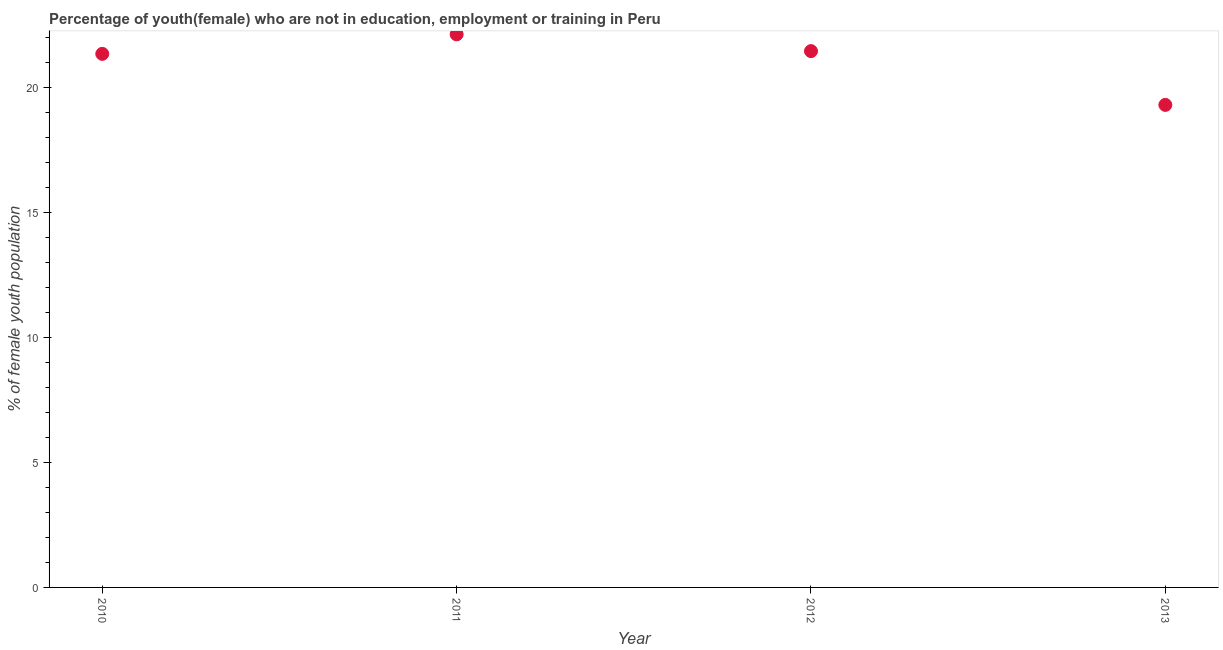What is the unemployed female youth population in 2012?
Your answer should be compact. 21.44. Across all years, what is the maximum unemployed female youth population?
Provide a succinct answer. 22.11. Across all years, what is the minimum unemployed female youth population?
Keep it short and to the point. 19.29. In which year was the unemployed female youth population minimum?
Offer a very short reply. 2013. What is the sum of the unemployed female youth population?
Provide a succinct answer. 84.17. What is the difference between the unemployed female youth population in 2010 and 2012?
Keep it short and to the point. -0.11. What is the average unemployed female youth population per year?
Your answer should be compact. 21.04. What is the median unemployed female youth population?
Your answer should be very brief. 21.39. What is the ratio of the unemployed female youth population in 2012 to that in 2013?
Ensure brevity in your answer.  1.11. Is the unemployed female youth population in 2011 less than that in 2012?
Offer a terse response. No. What is the difference between the highest and the second highest unemployed female youth population?
Provide a succinct answer. 0.67. Is the sum of the unemployed female youth population in 2011 and 2012 greater than the maximum unemployed female youth population across all years?
Your response must be concise. Yes. What is the difference between the highest and the lowest unemployed female youth population?
Keep it short and to the point. 2.82. In how many years, is the unemployed female youth population greater than the average unemployed female youth population taken over all years?
Make the answer very short. 3. Are the values on the major ticks of Y-axis written in scientific E-notation?
Give a very brief answer. No. Does the graph contain any zero values?
Offer a terse response. No. Does the graph contain grids?
Your answer should be compact. No. What is the title of the graph?
Offer a very short reply. Percentage of youth(female) who are not in education, employment or training in Peru. What is the label or title of the X-axis?
Provide a succinct answer. Year. What is the label or title of the Y-axis?
Your response must be concise. % of female youth population. What is the % of female youth population in 2010?
Your answer should be compact. 21.33. What is the % of female youth population in 2011?
Provide a succinct answer. 22.11. What is the % of female youth population in 2012?
Ensure brevity in your answer.  21.44. What is the % of female youth population in 2013?
Make the answer very short. 19.29. What is the difference between the % of female youth population in 2010 and 2011?
Offer a very short reply. -0.78. What is the difference between the % of female youth population in 2010 and 2012?
Your response must be concise. -0.11. What is the difference between the % of female youth population in 2010 and 2013?
Keep it short and to the point. 2.04. What is the difference between the % of female youth population in 2011 and 2012?
Your answer should be compact. 0.67. What is the difference between the % of female youth population in 2011 and 2013?
Your response must be concise. 2.82. What is the difference between the % of female youth population in 2012 and 2013?
Your answer should be very brief. 2.15. What is the ratio of the % of female youth population in 2010 to that in 2012?
Offer a terse response. 0.99. What is the ratio of the % of female youth population in 2010 to that in 2013?
Provide a short and direct response. 1.11. What is the ratio of the % of female youth population in 2011 to that in 2012?
Your response must be concise. 1.03. What is the ratio of the % of female youth population in 2011 to that in 2013?
Keep it short and to the point. 1.15. What is the ratio of the % of female youth population in 2012 to that in 2013?
Offer a very short reply. 1.11. 